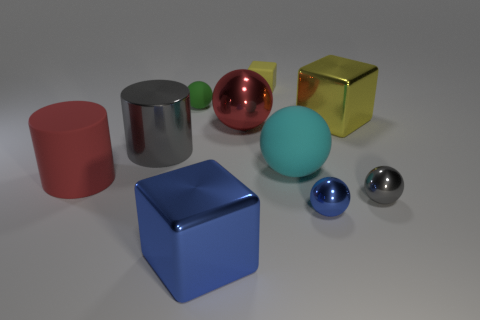There is a metal ball that is both on the left side of the small gray metallic object and behind the tiny blue shiny sphere; what size is it?
Your answer should be very brief. Large. What is the material of the blue thing that is the same size as the red metal object?
Your answer should be very brief. Metal. There is a shiny ball behind the gray object that is behind the large red cylinder; how many large rubber objects are to the left of it?
Offer a terse response. 1. There is a big rubber object that is on the left side of the big cyan thing; is it the same color as the matte ball in front of the tiny green rubber ball?
Offer a terse response. No. There is a tiny sphere that is both behind the small blue sphere and right of the large blue shiny block; what is its color?
Provide a short and direct response. Gray. How many yellow metallic cubes have the same size as the yellow metal thing?
Offer a very short reply. 0. There is a shiny object that is on the left side of the metal object in front of the blue sphere; what is its shape?
Offer a terse response. Cylinder. What is the shape of the gray shiny object that is in front of the red thing that is to the left of the tiny thing left of the tiny yellow thing?
Your answer should be very brief. Sphere. What number of green objects have the same shape as the large yellow metallic thing?
Keep it short and to the point. 0. There is a red object that is right of the red matte object; how many rubber objects are right of it?
Provide a short and direct response. 2. 